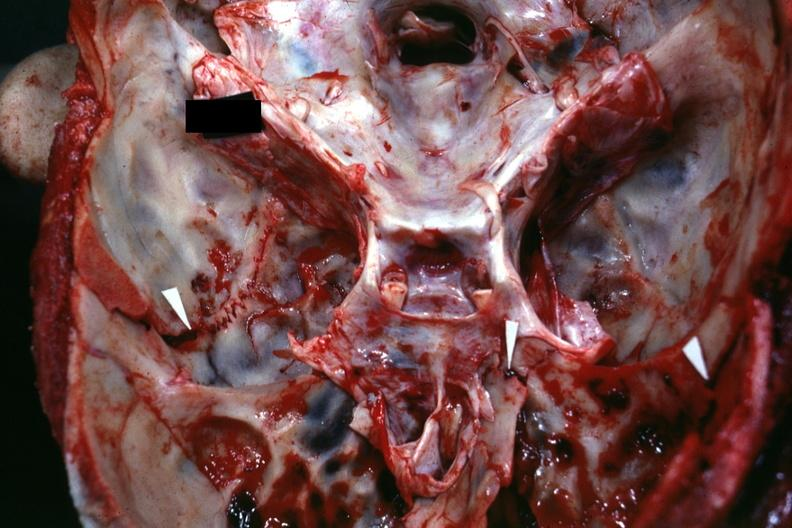s myoma lesion present?
Answer the question using a single word or phrase. No 